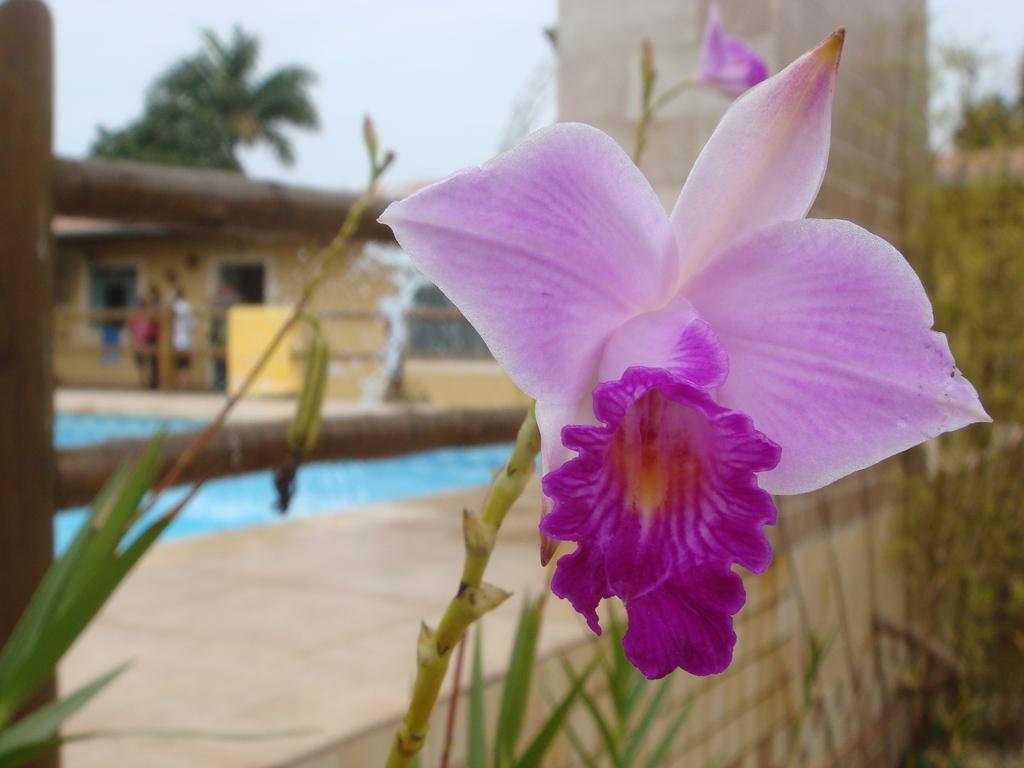Describe this image in one or two sentences. In this picture I can see the pink flower on the plant. In the back I can see the swimming pool. In front of the house I can see three persons were standing near to the wooden fencing. Beside them I can see the yellow color object. Behind the house I can see the trees. At the top I can see the sky. 